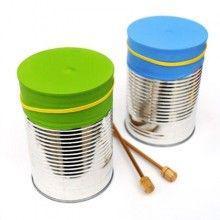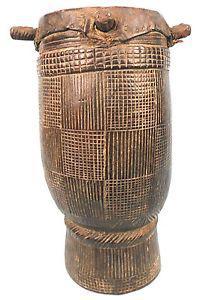The first image is the image on the left, the second image is the image on the right. For the images displayed, is the sentence "There is a single drum in the left image and two drums in the right image." factually correct? Answer yes or no. No. The first image is the image on the left, the second image is the image on the right. Considering the images on both sides, is "In at least one image there are duel wooden drums." valid? Answer yes or no. No. 